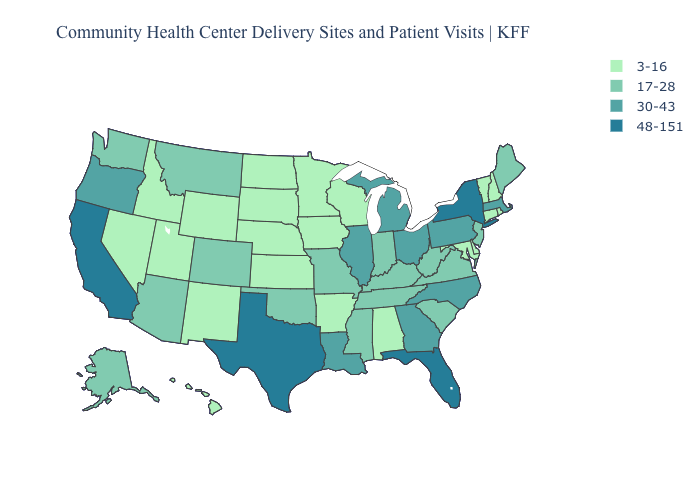Does the first symbol in the legend represent the smallest category?
Quick response, please. Yes. Which states hav the highest value in the Northeast?
Write a very short answer. New York. Among the states that border Maryland , which have the highest value?
Concise answer only. Pennsylvania. What is the value of Louisiana?
Short answer required. 30-43. Which states have the lowest value in the USA?
Be succinct. Alabama, Arkansas, Connecticut, Delaware, Hawaii, Idaho, Iowa, Kansas, Maryland, Minnesota, Nebraska, Nevada, New Hampshire, New Mexico, North Dakota, Rhode Island, South Dakota, Utah, Vermont, Wisconsin, Wyoming. Which states hav the highest value in the West?
Short answer required. California. Name the states that have a value in the range 48-151?
Write a very short answer. California, Florida, New York, Texas. Name the states that have a value in the range 30-43?
Answer briefly. Georgia, Illinois, Louisiana, Massachusetts, Michigan, North Carolina, Ohio, Oregon, Pennsylvania. Does Oregon have the lowest value in the West?
Be succinct. No. Among the states that border North Dakota , does Montana have the lowest value?
Be succinct. No. What is the value of Wyoming?
Short answer required. 3-16. Is the legend a continuous bar?
Write a very short answer. No. Which states hav the highest value in the MidWest?
Answer briefly. Illinois, Michigan, Ohio. Which states have the lowest value in the West?
Concise answer only. Hawaii, Idaho, Nevada, New Mexico, Utah, Wyoming. 